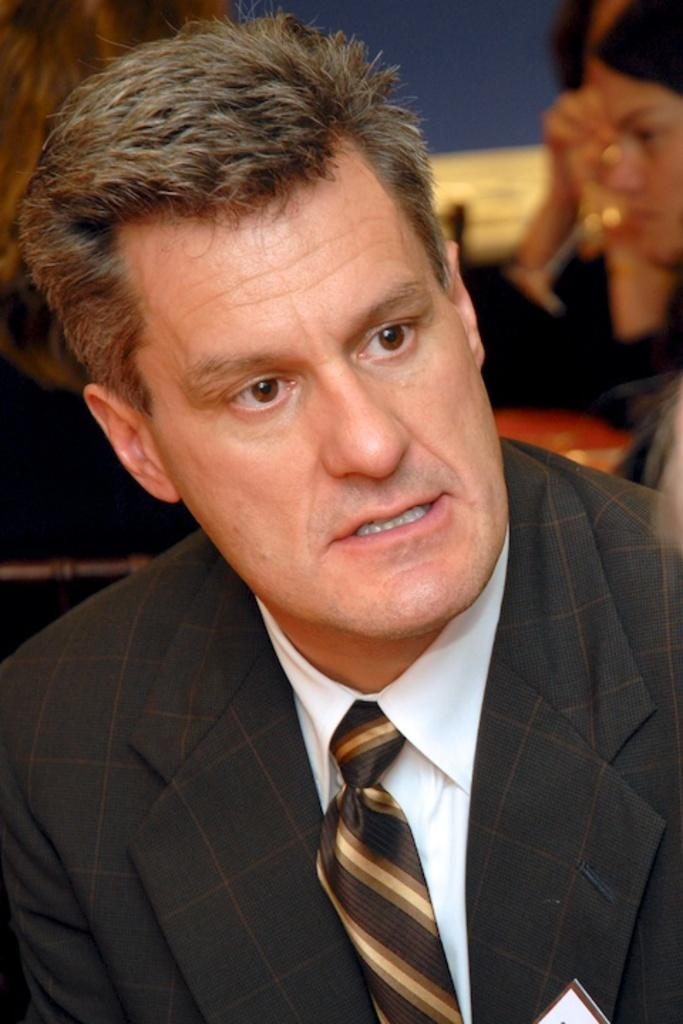What is the main subject of the image? There is a man in the image. Can you describe the man's attire? The man is wearing a black suit, a tie, and a white shirt. What can be seen in the background of the image? There are many people in the background of the image. Can you tell me what type of swing the man is using in the image? There is no swing present in the image; it features a man wearing a black suit, a tie, and a white shirt, with many people in the background. What is the man cooking in the image? There is no cooking activity depicted in the image; the man is simply dressed in a black suit, a tie, and a white shirt, with many people in the background. 